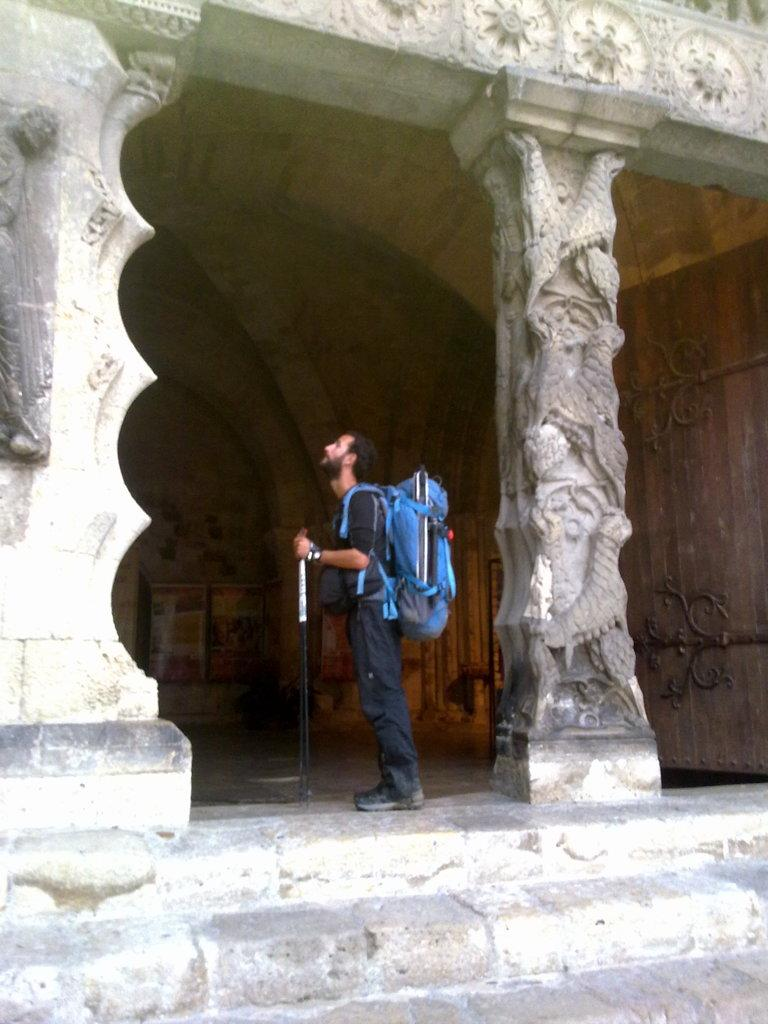What can be seen in the image? There is a person in the image, and they are holding an object and carrying a bag. What is the setting of the image? The image shows ground, stairs, pillars with carvings, a roof, and walls. Can you describe the person's actions in the image? The person is holding an object and carrying a bag. What unit of measurement is used to describe the size of the wish in the image? There is no wish present in the image, so it is not possible to determine a unit of measurement for its size. 